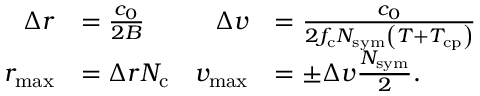Convert formula to latex. <formula><loc_0><loc_0><loc_500><loc_500>\begin{array} { r l r l } { \Delta r } & { = \frac { c _ { 0 } } { 2 B } } & { \Delta v } & { = \frac { c _ { 0 } } { 2 f _ { c } N _ { s y m } \left ( T + T _ { c p } \right ) } } \\ { r _ { \max } } & { = \Delta r N _ { c } } & { v _ { \max } } & { = \pm \Delta v \frac { N _ { s y m } } { 2 } . } \end{array}</formula> 